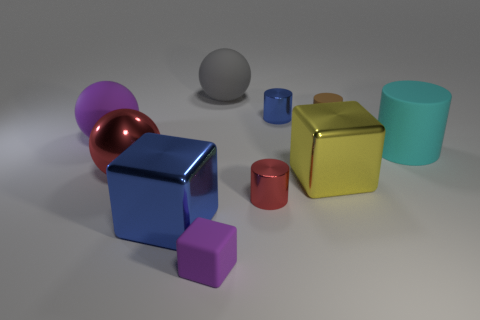What is the shape of the yellow metallic object that is the same size as the purple matte ball?
Provide a short and direct response. Cube. Is the size of the block that is to the right of the rubber cube the same as the large blue object?
Offer a very short reply. Yes. What is the material of the purple thing that is the same size as the yellow metallic object?
Provide a short and direct response. Rubber. There is a blue metallic thing that is behind the tiny thing that is to the right of the small blue thing; are there any red metallic objects to the left of it?
Offer a very short reply. Yes. Are there any other things that have the same shape as the big gray object?
Your answer should be very brief. Yes. There is a metallic cube that is left of the tiny purple rubber cube; is its color the same as the matte object left of the large blue metallic thing?
Your answer should be compact. No. Is there a tiny red matte thing?
Keep it short and to the point. No. There is a object that is the same color as the big metallic sphere; what is it made of?
Offer a terse response. Metal. What size is the thing behind the blue thing behind the red object that is behind the yellow thing?
Offer a very short reply. Large. Does the brown matte thing have the same shape as the red thing that is left of the small purple rubber block?
Provide a succinct answer. No. 